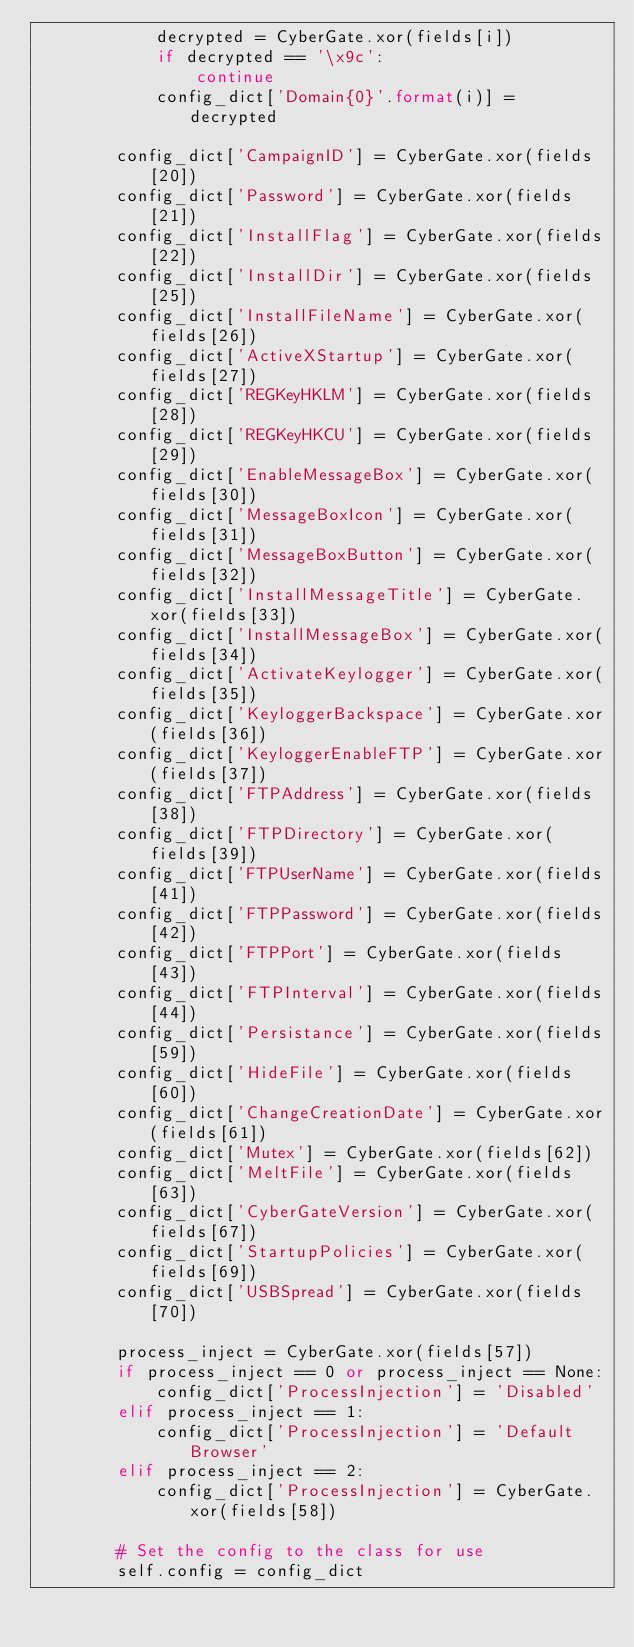Convert code to text. <code><loc_0><loc_0><loc_500><loc_500><_Python_>            decrypted = CyberGate.xor(fields[i])
            if decrypted == '\x9c':
                continue
            config_dict['Domain{0}'.format(i)] = decrypted
        
        config_dict['CampaignID'] = CyberGate.xor(fields[20])
        config_dict['Password'] = CyberGate.xor(fields[21])
        config_dict['InstallFlag'] = CyberGate.xor(fields[22])
        config_dict['InstallDir'] = CyberGate.xor(fields[25])
        config_dict['InstallFileName'] = CyberGate.xor(fields[26])
        config_dict['ActiveXStartup'] = CyberGate.xor(fields[27])
        config_dict['REGKeyHKLM'] = CyberGate.xor(fields[28])
        config_dict['REGKeyHKCU'] = CyberGate.xor(fields[29])
        config_dict['EnableMessageBox'] = CyberGate.xor(fields[30])
        config_dict['MessageBoxIcon'] = CyberGate.xor(fields[31])
        config_dict['MessageBoxButton'] = CyberGate.xor(fields[32])
        config_dict['InstallMessageTitle'] = CyberGate.xor(fields[33])
        config_dict['InstallMessageBox'] = CyberGate.xor(fields[34])
        config_dict['ActivateKeylogger'] = CyberGate.xor(fields[35])
        config_dict['KeyloggerBackspace'] = CyberGate.xor(fields[36])
        config_dict['KeyloggerEnableFTP'] = CyberGate.xor(fields[37])
        config_dict['FTPAddress'] = CyberGate.xor(fields[38])
        config_dict['FTPDirectory'] = CyberGate.xor(fields[39])
        config_dict['FTPUserName'] = CyberGate.xor(fields[41])
        config_dict['FTPPassword'] = CyberGate.xor(fields[42])
        config_dict['FTPPort'] = CyberGate.xor(fields[43])
        config_dict['FTPInterval'] = CyberGate.xor(fields[44])
        config_dict['Persistance'] = CyberGate.xor(fields[59])
        config_dict['HideFile'] = CyberGate.xor(fields[60])
        config_dict['ChangeCreationDate'] = CyberGate.xor(fields[61])
        config_dict['Mutex'] = CyberGate.xor(fields[62])
        config_dict['MeltFile'] = CyberGate.xor(fields[63])
        config_dict['CyberGateVersion'] = CyberGate.xor(fields[67])
        config_dict['StartupPolicies'] = CyberGate.xor(fields[69])
        config_dict['USBSpread'] = CyberGate.xor(fields[70])

        process_inject = CyberGate.xor(fields[57])
        if process_inject == 0 or process_inject == None:
            config_dict['ProcessInjection'] = 'Disabled'
        elif process_inject == 1:
            config_dict['ProcessInjection'] = 'Default Browser'
        elif process_inject == 2:
            config_dict['ProcessInjection'] = CyberGate.xor(fields[58])

        # Set the config to the class for use
        self.config = config_dict
</code> 